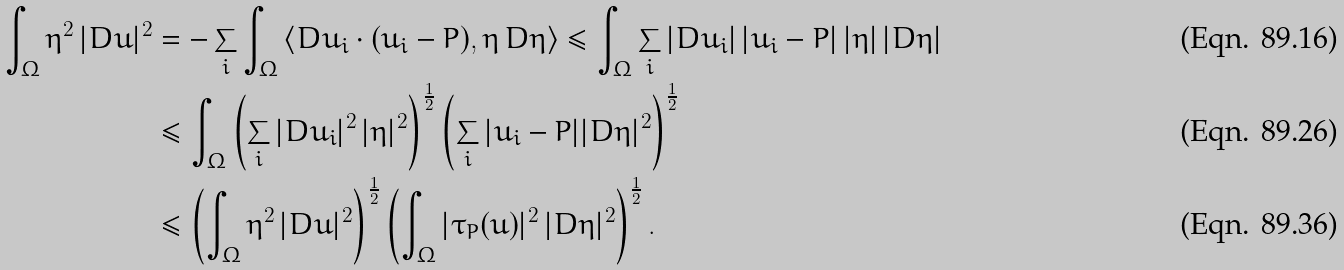Convert formula to latex. <formula><loc_0><loc_0><loc_500><loc_500>\int _ { \Omega } \eta ^ { 2 } \, | D u | ^ { 2 } & = - \sum _ { i } \int _ { \Omega } \left \langle D u _ { i } \cdot ( u _ { i } - P ) , \eta \, D \eta \right \rangle \leq \int _ { \Omega } \sum _ { i } | D u _ { i } | \, | u _ { i } - P | \, | \eta | \, | D \eta | \\ & \leq \int _ { \Omega } \left ( \sum _ { i } | D u _ { i } | ^ { 2 } \, | \eta | ^ { 2 } \right ) ^ { \frac { 1 } { 2 } } \left ( \sum _ { i } | u _ { i } - P | | D \eta | ^ { 2 } \right ) ^ { \frac { 1 } { 2 } } \\ & \leq \left ( \int _ { \Omega } \eta ^ { 2 } \, | D u | ^ { 2 } \right ) ^ { \frac { 1 } { 2 } } \left ( \int _ { \Omega } | \tau _ { P } ( u ) | ^ { 2 } \, | D \eta | ^ { 2 } \right ) ^ { \frac { 1 } { 2 } } .</formula> 